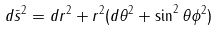<formula> <loc_0><loc_0><loc_500><loc_500>d \bar { s } ^ { 2 } = d r ^ { 2 } + r ^ { 2 } ( d \theta ^ { 2 } + \sin ^ { 2 } \theta \phi ^ { 2 } )</formula> 